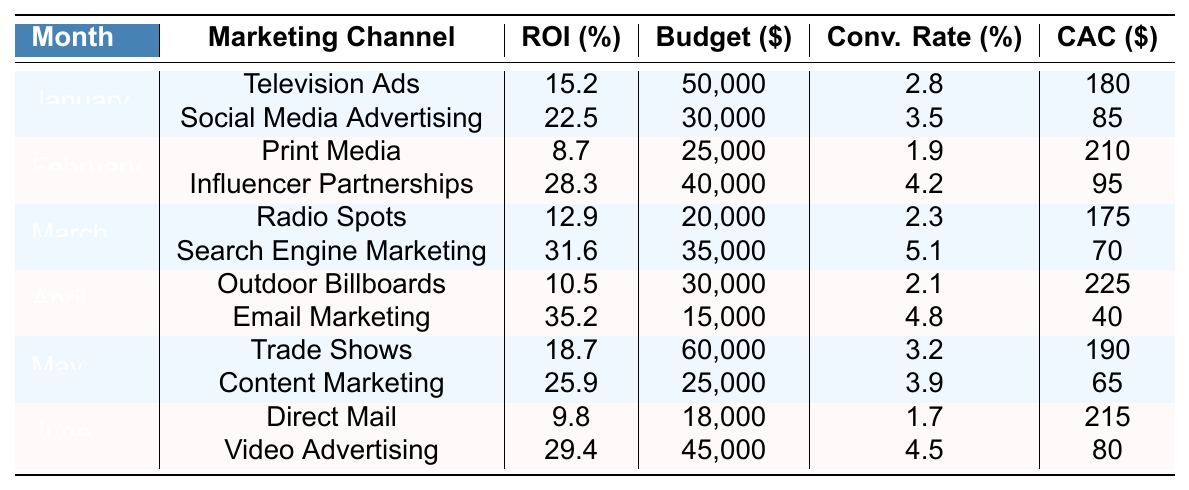What was the highest ROI recorded in January? In January, the ROIs for the two channels were 15.2% for Television Ads and 22.5% for Social Media Advertising. The highest ROI is 22.5%.
Answer: 22.5% Which marketing channel had the best ROI in February? In February, the ROI for Print Media was 8.7% and for Influencer Partnerships was 28.3%. The best ROI is 28.3% for Influencer Partnerships.
Answer: Influencer Partnerships What is the total budget allocated for March marketing channels? The budget allocation for March channels are $20,000 for Radio Spots and $35,000 for Search Engine Marketing. So, the total budget is 20,000 + 35,000 = 55,000.
Answer: $55,000 Did Email Marketing have a higher or lower ROI compared to Outdoor Billboards in April? Email Marketing had a ROI of 35.2%, while Outdoor Billboards had a ROI of 10.5%. Since 35.2% is greater than 10.5%, it is higher.
Answer: Higher What is the average ROI across the marketing channels for June? The ROIs for June are 9.8% for Direct Mail and 29.4% for Video Advertising. To find the average, add the two: 9.8 + 29.4 = 39.2, then divide by 2: 39.2 / 2 = 19.6.
Answer: 19.6% Which month had the highest customer acquisition cost for a marketing channel? Review the Customer Acquisition Costs: January's highest is $180, February is $210, March is $175, April is $225, May is $190, June is $215. The highest is $225 in April.
Answer: April What is the total conversion rate for May's marketing channels? In May, the Conversion Rates are 3.2% for Trade Shows and 3.9% for Content Marketing. To total them: 3.2 + 3.9 = 7.1%.
Answer: 7.1% Is the ROI from Social Media Advertising greater than the ROI from Print Media in February? The ROI for Social Media Advertising in January is 22.5%, and the ROI for Print Media in February is 8.7%. Since 22.5% is greater than 8.7%, the answer is yes.
Answer: Yes Which marketing channel had the lowest customer acquisition cost across all months? The lowest Customer Acquisition Cost is $40 for Email Marketing in April. Comparing across all months, it is the minimum.
Answer: $40 How much budget was allocated for Influencer Partnerships in February? The budget allocation for Influencer Partnerships in February is $40,000 as per the data provided.
Answer: $40,000 